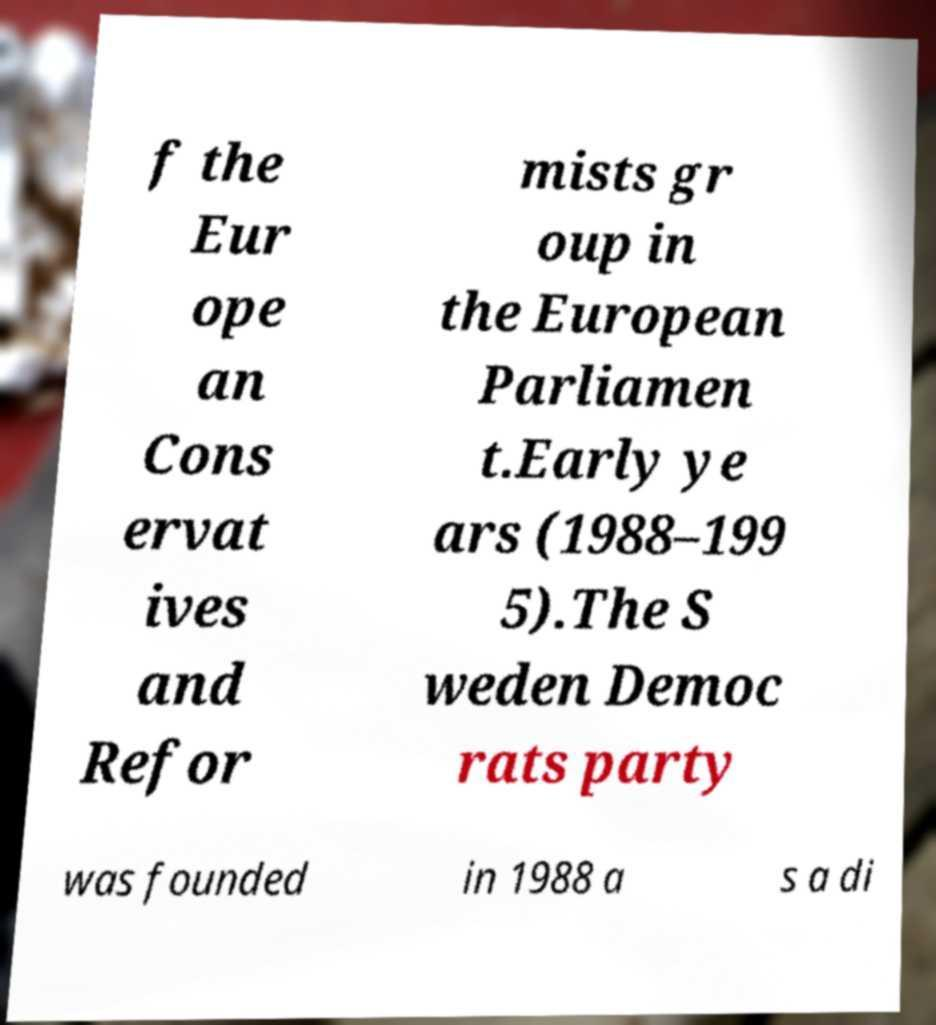Could you assist in decoding the text presented in this image and type it out clearly? f the Eur ope an Cons ervat ives and Refor mists gr oup in the European Parliamen t.Early ye ars (1988–199 5).The S weden Democ rats party was founded in 1988 a s a di 